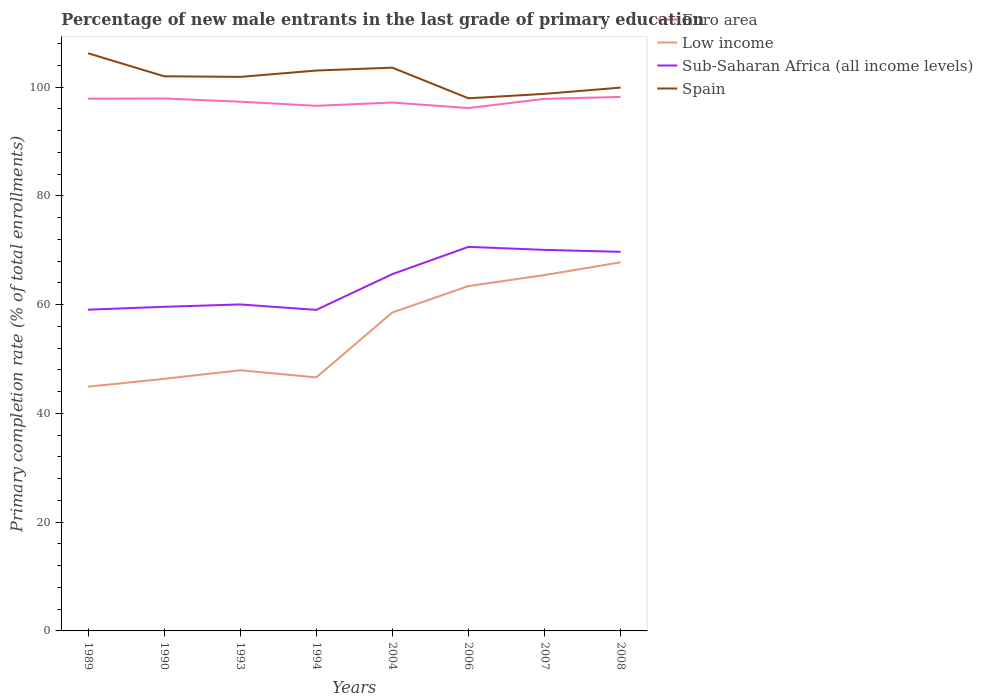How many different coloured lines are there?
Provide a short and direct response. 4. Across all years, what is the maximum percentage of new male entrants in Low income?
Offer a terse response. 44.9. In which year was the percentage of new male entrants in Low income maximum?
Offer a terse response. 1989. What is the total percentage of new male entrants in Low income in the graph?
Make the answer very short. -1.45. What is the difference between the highest and the second highest percentage of new male entrants in Sub-Saharan Africa (all income levels)?
Your response must be concise. 11.58. Is the percentage of new male entrants in Euro area strictly greater than the percentage of new male entrants in Sub-Saharan Africa (all income levels) over the years?
Your answer should be compact. No. How many lines are there?
Keep it short and to the point. 4. What is the difference between two consecutive major ticks on the Y-axis?
Offer a very short reply. 20. Are the values on the major ticks of Y-axis written in scientific E-notation?
Your answer should be compact. No. Where does the legend appear in the graph?
Offer a terse response. Top right. What is the title of the graph?
Keep it short and to the point. Percentage of new male entrants in the last grade of primary education. What is the label or title of the X-axis?
Your answer should be very brief. Years. What is the label or title of the Y-axis?
Give a very brief answer. Primary completion rate (% of total enrollments). What is the Primary completion rate (% of total enrollments) of Euro area in 1989?
Give a very brief answer. 97.86. What is the Primary completion rate (% of total enrollments) in Low income in 1989?
Offer a very short reply. 44.9. What is the Primary completion rate (% of total enrollments) in Sub-Saharan Africa (all income levels) in 1989?
Your answer should be compact. 59.07. What is the Primary completion rate (% of total enrollments) in Spain in 1989?
Provide a succinct answer. 106.22. What is the Primary completion rate (% of total enrollments) of Euro area in 1990?
Your answer should be very brief. 97.9. What is the Primary completion rate (% of total enrollments) of Low income in 1990?
Make the answer very short. 46.35. What is the Primary completion rate (% of total enrollments) of Sub-Saharan Africa (all income levels) in 1990?
Give a very brief answer. 59.6. What is the Primary completion rate (% of total enrollments) of Spain in 1990?
Your answer should be very brief. 101.98. What is the Primary completion rate (% of total enrollments) of Euro area in 1993?
Your answer should be very brief. 97.31. What is the Primary completion rate (% of total enrollments) of Low income in 1993?
Your answer should be very brief. 47.93. What is the Primary completion rate (% of total enrollments) of Sub-Saharan Africa (all income levels) in 1993?
Your answer should be very brief. 60.03. What is the Primary completion rate (% of total enrollments) of Spain in 1993?
Your response must be concise. 101.87. What is the Primary completion rate (% of total enrollments) in Euro area in 1994?
Your response must be concise. 96.55. What is the Primary completion rate (% of total enrollments) of Low income in 1994?
Your answer should be very brief. 46.62. What is the Primary completion rate (% of total enrollments) in Sub-Saharan Africa (all income levels) in 1994?
Offer a terse response. 59.03. What is the Primary completion rate (% of total enrollments) of Spain in 1994?
Offer a very short reply. 103.04. What is the Primary completion rate (% of total enrollments) in Euro area in 2004?
Make the answer very short. 97.16. What is the Primary completion rate (% of total enrollments) in Low income in 2004?
Your answer should be compact. 58.55. What is the Primary completion rate (% of total enrollments) in Sub-Saharan Africa (all income levels) in 2004?
Your response must be concise. 65.61. What is the Primary completion rate (% of total enrollments) of Spain in 2004?
Make the answer very short. 103.57. What is the Primary completion rate (% of total enrollments) of Euro area in 2006?
Your answer should be compact. 96.14. What is the Primary completion rate (% of total enrollments) in Low income in 2006?
Your response must be concise. 63.41. What is the Primary completion rate (% of total enrollments) in Sub-Saharan Africa (all income levels) in 2006?
Give a very brief answer. 70.62. What is the Primary completion rate (% of total enrollments) of Spain in 2006?
Give a very brief answer. 97.93. What is the Primary completion rate (% of total enrollments) of Euro area in 2007?
Your answer should be compact. 97.84. What is the Primary completion rate (% of total enrollments) in Low income in 2007?
Your answer should be compact. 65.43. What is the Primary completion rate (% of total enrollments) in Sub-Saharan Africa (all income levels) in 2007?
Offer a very short reply. 70.06. What is the Primary completion rate (% of total enrollments) of Spain in 2007?
Keep it short and to the point. 98.75. What is the Primary completion rate (% of total enrollments) in Euro area in 2008?
Your answer should be very brief. 98.19. What is the Primary completion rate (% of total enrollments) in Low income in 2008?
Give a very brief answer. 67.78. What is the Primary completion rate (% of total enrollments) in Sub-Saharan Africa (all income levels) in 2008?
Offer a terse response. 69.7. What is the Primary completion rate (% of total enrollments) of Spain in 2008?
Your response must be concise. 99.9. Across all years, what is the maximum Primary completion rate (% of total enrollments) in Euro area?
Make the answer very short. 98.19. Across all years, what is the maximum Primary completion rate (% of total enrollments) in Low income?
Offer a terse response. 67.78. Across all years, what is the maximum Primary completion rate (% of total enrollments) in Sub-Saharan Africa (all income levels)?
Your answer should be very brief. 70.62. Across all years, what is the maximum Primary completion rate (% of total enrollments) in Spain?
Give a very brief answer. 106.22. Across all years, what is the minimum Primary completion rate (% of total enrollments) in Euro area?
Your answer should be compact. 96.14. Across all years, what is the minimum Primary completion rate (% of total enrollments) of Low income?
Your answer should be very brief. 44.9. Across all years, what is the minimum Primary completion rate (% of total enrollments) in Sub-Saharan Africa (all income levels)?
Ensure brevity in your answer.  59.03. Across all years, what is the minimum Primary completion rate (% of total enrollments) in Spain?
Your response must be concise. 97.93. What is the total Primary completion rate (% of total enrollments) in Euro area in the graph?
Offer a terse response. 778.95. What is the total Primary completion rate (% of total enrollments) of Low income in the graph?
Keep it short and to the point. 440.97. What is the total Primary completion rate (% of total enrollments) of Sub-Saharan Africa (all income levels) in the graph?
Give a very brief answer. 513.72. What is the total Primary completion rate (% of total enrollments) in Spain in the graph?
Your answer should be compact. 813.26. What is the difference between the Primary completion rate (% of total enrollments) of Euro area in 1989 and that in 1990?
Your answer should be very brief. -0.04. What is the difference between the Primary completion rate (% of total enrollments) of Low income in 1989 and that in 1990?
Your answer should be very brief. -1.45. What is the difference between the Primary completion rate (% of total enrollments) in Sub-Saharan Africa (all income levels) in 1989 and that in 1990?
Offer a very short reply. -0.53. What is the difference between the Primary completion rate (% of total enrollments) in Spain in 1989 and that in 1990?
Your response must be concise. 4.23. What is the difference between the Primary completion rate (% of total enrollments) in Euro area in 1989 and that in 1993?
Your answer should be compact. 0.55. What is the difference between the Primary completion rate (% of total enrollments) of Low income in 1989 and that in 1993?
Provide a short and direct response. -3.02. What is the difference between the Primary completion rate (% of total enrollments) of Sub-Saharan Africa (all income levels) in 1989 and that in 1993?
Your response must be concise. -0.96. What is the difference between the Primary completion rate (% of total enrollments) of Spain in 1989 and that in 1993?
Make the answer very short. 4.35. What is the difference between the Primary completion rate (% of total enrollments) of Euro area in 1989 and that in 1994?
Ensure brevity in your answer.  1.31. What is the difference between the Primary completion rate (% of total enrollments) of Low income in 1989 and that in 1994?
Ensure brevity in your answer.  -1.72. What is the difference between the Primary completion rate (% of total enrollments) in Sub-Saharan Africa (all income levels) in 1989 and that in 1994?
Offer a very short reply. 0.03. What is the difference between the Primary completion rate (% of total enrollments) of Spain in 1989 and that in 1994?
Give a very brief answer. 3.18. What is the difference between the Primary completion rate (% of total enrollments) of Euro area in 1989 and that in 2004?
Ensure brevity in your answer.  0.7. What is the difference between the Primary completion rate (% of total enrollments) of Low income in 1989 and that in 2004?
Your answer should be compact. -13.65. What is the difference between the Primary completion rate (% of total enrollments) of Sub-Saharan Africa (all income levels) in 1989 and that in 2004?
Your answer should be compact. -6.54. What is the difference between the Primary completion rate (% of total enrollments) in Spain in 1989 and that in 2004?
Make the answer very short. 2.65. What is the difference between the Primary completion rate (% of total enrollments) of Euro area in 1989 and that in 2006?
Make the answer very short. 1.73. What is the difference between the Primary completion rate (% of total enrollments) in Low income in 1989 and that in 2006?
Make the answer very short. -18.51. What is the difference between the Primary completion rate (% of total enrollments) of Sub-Saharan Africa (all income levels) in 1989 and that in 2006?
Provide a short and direct response. -11.55. What is the difference between the Primary completion rate (% of total enrollments) of Spain in 1989 and that in 2006?
Keep it short and to the point. 8.28. What is the difference between the Primary completion rate (% of total enrollments) in Euro area in 1989 and that in 2007?
Your answer should be very brief. 0.03. What is the difference between the Primary completion rate (% of total enrollments) in Low income in 1989 and that in 2007?
Your answer should be very brief. -20.53. What is the difference between the Primary completion rate (% of total enrollments) in Sub-Saharan Africa (all income levels) in 1989 and that in 2007?
Offer a terse response. -11. What is the difference between the Primary completion rate (% of total enrollments) in Spain in 1989 and that in 2007?
Your answer should be compact. 7.47. What is the difference between the Primary completion rate (% of total enrollments) in Euro area in 1989 and that in 2008?
Ensure brevity in your answer.  -0.32. What is the difference between the Primary completion rate (% of total enrollments) in Low income in 1989 and that in 2008?
Offer a terse response. -22.88. What is the difference between the Primary completion rate (% of total enrollments) of Sub-Saharan Africa (all income levels) in 1989 and that in 2008?
Your answer should be very brief. -10.64. What is the difference between the Primary completion rate (% of total enrollments) in Spain in 1989 and that in 2008?
Your answer should be very brief. 6.32. What is the difference between the Primary completion rate (% of total enrollments) in Euro area in 1990 and that in 1993?
Provide a succinct answer. 0.59. What is the difference between the Primary completion rate (% of total enrollments) in Low income in 1990 and that in 1993?
Give a very brief answer. -1.57. What is the difference between the Primary completion rate (% of total enrollments) of Sub-Saharan Africa (all income levels) in 1990 and that in 1993?
Provide a short and direct response. -0.43. What is the difference between the Primary completion rate (% of total enrollments) in Spain in 1990 and that in 1993?
Offer a very short reply. 0.11. What is the difference between the Primary completion rate (% of total enrollments) of Euro area in 1990 and that in 1994?
Your response must be concise. 1.35. What is the difference between the Primary completion rate (% of total enrollments) in Low income in 1990 and that in 1994?
Offer a very short reply. -0.27. What is the difference between the Primary completion rate (% of total enrollments) in Sub-Saharan Africa (all income levels) in 1990 and that in 1994?
Provide a succinct answer. 0.56. What is the difference between the Primary completion rate (% of total enrollments) of Spain in 1990 and that in 1994?
Provide a short and direct response. -1.05. What is the difference between the Primary completion rate (% of total enrollments) of Euro area in 1990 and that in 2004?
Ensure brevity in your answer.  0.74. What is the difference between the Primary completion rate (% of total enrollments) in Low income in 1990 and that in 2004?
Keep it short and to the point. -12.2. What is the difference between the Primary completion rate (% of total enrollments) of Sub-Saharan Africa (all income levels) in 1990 and that in 2004?
Keep it short and to the point. -6.01. What is the difference between the Primary completion rate (% of total enrollments) in Spain in 1990 and that in 2004?
Keep it short and to the point. -1.58. What is the difference between the Primary completion rate (% of total enrollments) of Euro area in 1990 and that in 2006?
Provide a short and direct response. 1.77. What is the difference between the Primary completion rate (% of total enrollments) in Low income in 1990 and that in 2006?
Make the answer very short. -17.06. What is the difference between the Primary completion rate (% of total enrollments) of Sub-Saharan Africa (all income levels) in 1990 and that in 2006?
Make the answer very short. -11.02. What is the difference between the Primary completion rate (% of total enrollments) of Spain in 1990 and that in 2006?
Offer a terse response. 4.05. What is the difference between the Primary completion rate (% of total enrollments) of Euro area in 1990 and that in 2007?
Offer a terse response. 0.06. What is the difference between the Primary completion rate (% of total enrollments) of Low income in 1990 and that in 2007?
Your answer should be very brief. -19.08. What is the difference between the Primary completion rate (% of total enrollments) in Sub-Saharan Africa (all income levels) in 1990 and that in 2007?
Provide a succinct answer. -10.47. What is the difference between the Primary completion rate (% of total enrollments) of Spain in 1990 and that in 2007?
Offer a very short reply. 3.23. What is the difference between the Primary completion rate (% of total enrollments) of Euro area in 1990 and that in 2008?
Your response must be concise. -0.29. What is the difference between the Primary completion rate (% of total enrollments) of Low income in 1990 and that in 2008?
Offer a terse response. -21.43. What is the difference between the Primary completion rate (% of total enrollments) of Sub-Saharan Africa (all income levels) in 1990 and that in 2008?
Provide a succinct answer. -10.11. What is the difference between the Primary completion rate (% of total enrollments) of Spain in 1990 and that in 2008?
Your answer should be very brief. 2.09. What is the difference between the Primary completion rate (% of total enrollments) of Euro area in 1993 and that in 1994?
Your answer should be very brief. 0.76. What is the difference between the Primary completion rate (% of total enrollments) of Low income in 1993 and that in 1994?
Make the answer very short. 1.31. What is the difference between the Primary completion rate (% of total enrollments) in Sub-Saharan Africa (all income levels) in 1993 and that in 1994?
Give a very brief answer. 1. What is the difference between the Primary completion rate (% of total enrollments) in Spain in 1993 and that in 1994?
Offer a terse response. -1.17. What is the difference between the Primary completion rate (% of total enrollments) of Euro area in 1993 and that in 2004?
Keep it short and to the point. 0.15. What is the difference between the Primary completion rate (% of total enrollments) of Low income in 1993 and that in 2004?
Your response must be concise. -10.63. What is the difference between the Primary completion rate (% of total enrollments) in Sub-Saharan Africa (all income levels) in 1993 and that in 2004?
Offer a terse response. -5.58. What is the difference between the Primary completion rate (% of total enrollments) in Spain in 1993 and that in 2004?
Your response must be concise. -1.7. What is the difference between the Primary completion rate (% of total enrollments) in Euro area in 1993 and that in 2006?
Your answer should be compact. 1.17. What is the difference between the Primary completion rate (% of total enrollments) in Low income in 1993 and that in 2006?
Your answer should be very brief. -15.49. What is the difference between the Primary completion rate (% of total enrollments) of Sub-Saharan Africa (all income levels) in 1993 and that in 2006?
Keep it short and to the point. -10.59. What is the difference between the Primary completion rate (% of total enrollments) of Spain in 1993 and that in 2006?
Your answer should be compact. 3.94. What is the difference between the Primary completion rate (% of total enrollments) of Euro area in 1993 and that in 2007?
Your answer should be very brief. -0.53. What is the difference between the Primary completion rate (% of total enrollments) in Low income in 1993 and that in 2007?
Offer a terse response. -17.5. What is the difference between the Primary completion rate (% of total enrollments) in Sub-Saharan Africa (all income levels) in 1993 and that in 2007?
Provide a succinct answer. -10.03. What is the difference between the Primary completion rate (% of total enrollments) in Spain in 1993 and that in 2007?
Your answer should be very brief. 3.12. What is the difference between the Primary completion rate (% of total enrollments) in Euro area in 1993 and that in 2008?
Provide a short and direct response. -0.88. What is the difference between the Primary completion rate (% of total enrollments) in Low income in 1993 and that in 2008?
Give a very brief answer. -19.85. What is the difference between the Primary completion rate (% of total enrollments) of Sub-Saharan Africa (all income levels) in 1993 and that in 2008?
Ensure brevity in your answer.  -9.67. What is the difference between the Primary completion rate (% of total enrollments) of Spain in 1993 and that in 2008?
Offer a very short reply. 1.97. What is the difference between the Primary completion rate (% of total enrollments) of Euro area in 1994 and that in 2004?
Offer a very short reply. -0.61. What is the difference between the Primary completion rate (% of total enrollments) in Low income in 1994 and that in 2004?
Offer a very short reply. -11.93. What is the difference between the Primary completion rate (% of total enrollments) of Sub-Saharan Africa (all income levels) in 1994 and that in 2004?
Keep it short and to the point. -6.57. What is the difference between the Primary completion rate (% of total enrollments) of Spain in 1994 and that in 2004?
Offer a terse response. -0.53. What is the difference between the Primary completion rate (% of total enrollments) of Euro area in 1994 and that in 2006?
Offer a very short reply. 0.41. What is the difference between the Primary completion rate (% of total enrollments) of Low income in 1994 and that in 2006?
Your response must be concise. -16.79. What is the difference between the Primary completion rate (% of total enrollments) in Sub-Saharan Africa (all income levels) in 1994 and that in 2006?
Your answer should be compact. -11.58. What is the difference between the Primary completion rate (% of total enrollments) in Spain in 1994 and that in 2006?
Ensure brevity in your answer.  5.1. What is the difference between the Primary completion rate (% of total enrollments) in Euro area in 1994 and that in 2007?
Make the answer very short. -1.29. What is the difference between the Primary completion rate (% of total enrollments) of Low income in 1994 and that in 2007?
Provide a succinct answer. -18.81. What is the difference between the Primary completion rate (% of total enrollments) in Sub-Saharan Africa (all income levels) in 1994 and that in 2007?
Give a very brief answer. -11.03. What is the difference between the Primary completion rate (% of total enrollments) of Spain in 1994 and that in 2007?
Your response must be concise. 4.29. What is the difference between the Primary completion rate (% of total enrollments) in Euro area in 1994 and that in 2008?
Provide a succinct answer. -1.64. What is the difference between the Primary completion rate (% of total enrollments) in Low income in 1994 and that in 2008?
Make the answer very short. -21.16. What is the difference between the Primary completion rate (% of total enrollments) of Sub-Saharan Africa (all income levels) in 1994 and that in 2008?
Make the answer very short. -10.67. What is the difference between the Primary completion rate (% of total enrollments) of Spain in 1994 and that in 2008?
Offer a very short reply. 3.14. What is the difference between the Primary completion rate (% of total enrollments) of Euro area in 2004 and that in 2006?
Your response must be concise. 1.02. What is the difference between the Primary completion rate (% of total enrollments) of Low income in 2004 and that in 2006?
Provide a short and direct response. -4.86. What is the difference between the Primary completion rate (% of total enrollments) in Sub-Saharan Africa (all income levels) in 2004 and that in 2006?
Your answer should be compact. -5.01. What is the difference between the Primary completion rate (% of total enrollments) of Spain in 2004 and that in 2006?
Make the answer very short. 5.63. What is the difference between the Primary completion rate (% of total enrollments) in Euro area in 2004 and that in 2007?
Offer a terse response. -0.68. What is the difference between the Primary completion rate (% of total enrollments) in Low income in 2004 and that in 2007?
Your answer should be very brief. -6.88. What is the difference between the Primary completion rate (% of total enrollments) of Sub-Saharan Africa (all income levels) in 2004 and that in 2007?
Provide a succinct answer. -4.46. What is the difference between the Primary completion rate (% of total enrollments) of Spain in 2004 and that in 2007?
Provide a short and direct response. 4.82. What is the difference between the Primary completion rate (% of total enrollments) in Euro area in 2004 and that in 2008?
Offer a terse response. -1.03. What is the difference between the Primary completion rate (% of total enrollments) in Low income in 2004 and that in 2008?
Offer a very short reply. -9.23. What is the difference between the Primary completion rate (% of total enrollments) in Sub-Saharan Africa (all income levels) in 2004 and that in 2008?
Provide a succinct answer. -4.1. What is the difference between the Primary completion rate (% of total enrollments) in Spain in 2004 and that in 2008?
Ensure brevity in your answer.  3.67. What is the difference between the Primary completion rate (% of total enrollments) of Euro area in 2006 and that in 2007?
Offer a very short reply. -1.7. What is the difference between the Primary completion rate (% of total enrollments) in Low income in 2006 and that in 2007?
Ensure brevity in your answer.  -2.02. What is the difference between the Primary completion rate (% of total enrollments) of Sub-Saharan Africa (all income levels) in 2006 and that in 2007?
Ensure brevity in your answer.  0.55. What is the difference between the Primary completion rate (% of total enrollments) of Spain in 2006 and that in 2007?
Offer a very short reply. -0.82. What is the difference between the Primary completion rate (% of total enrollments) of Euro area in 2006 and that in 2008?
Make the answer very short. -2.05. What is the difference between the Primary completion rate (% of total enrollments) of Low income in 2006 and that in 2008?
Provide a short and direct response. -4.37. What is the difference between the Primary completion rate (% of total enrollments) of Sub-Saharan Africa (all income levels) in 2006 and that in 2008?
Make the answer very short. 0.91. What is the difference between the Primary completion rate (% of total enrollments) of Spain in 2006 and that in 2008?
Your answer should be very brief. -1.97. What is the difference between the Primary completion rate (% of total enrollments) in Euro area in 2007 and that in 2008?
Provide a short and direct response. -0.35. What is the difference between the Primary completion rate (% of total enrollments) in Low income in 2007 and that in 2008?
Provide a short and direct response. -2.35. What is the difference between the Primary completion rate (% of total enrollments) of Sub-Saharan Africa (all income levels) in 2007 and that in 2008?
Make the answer very short. 0.36. What is the difference between the Primary completion rate (% of total enrollments) of Spain in 2007 and that in 2008?
Your response must be concise. -1.15. What is the difference between the Primary completion rate (% of total enrollments) of Euro area in 1989 and the Primary completion rate (% of total enrollments) of Low income in 1990?
Offer a terse response. 51.51. What is the difference between the Primary completion rate (% of total enrollments) of Euro area in 1989 and the Primary completion rate (% of total enrollments) of Sub-Saharan Africa (all income levels) in 1990?
Your response must be concise. 38.27. What is the difference between the Primary completion rate (% of total enrollments) of Euro area in 1989 and the Primary completion rate (% of total enrollments) of Spain in 1990?
Offer a very short reply. -4.12. What is the difference between the Primary completion rate (% of total enrollments) of Low income in 1989 and the Primary completion rate (% of total enrollments) of Sub-Saharan Africa (all income levels) in 1990?
Give a very brief answer. -14.69. What is the difference between the Primary completion rate (% of total enrollments) in Low income in 1989 and the Primary completion rate (% of total enrollments) in Spain in 1990?
Offer a terse response. -57.08. What is the difference between the Primary completion rate (% of total enrollments) of Sub-Saharan Africa (all income levels) in 1989 and the Primary completion rate (% of total enrollments) of Spain in 1990?
Keep it short and to the point. -42.92. What is the difference between the Primary completion rate (% of total enrollments) of Euro area in 1989 and the Primary completion rate (% of total enrollments) of Low income in 1993?
Provide a succinct answer. 49.94. What is the difference between the Primary completion rate (% of total enrollments) of Euro area in 1989 and the Primary completion rate (% of total enrollments) of Sub-Saharan Africa (all income levels) in 1993?
Offer a terse response. 37.83. What is the difference between the Primary completion rate (% of total enrollments) of Euro area in 1989 and the Primary completion rate (% of total enrollments) of Spain in 1993?
Your answer should be very brief. -4.01. What is the difference between the Primary completion rate (% of total enrollments) of Low income in 1989 and the Primary completion rate (% of total enrollments) of Sub-Saharan Africa (all income levels) in 1993?
Keep it short and to the point. -15.13. What is the difference between the Primary completion rate (% of total enrollments) of Low income in 1989 and the Primary completion rate (% of total enrollments) of Spain in 1993?
Give a very brief answer. -56.97. What is the difference between the Primary completion rate (% of total enrollments) in Sub-Saharan Africa (all income levels) in 1989 and the Primary completion rate (% of total enrollments) in Spain in 1993?
Provide a succinct answer. -42.8. What is the difference between the Primary completion rate (% of total enrollments) in Euro area in 1989 and the Primary completion rate (% of total enrollments) in Low income in 1994?
Make the answer very short. 51.24. What is the difference between the Primary completion rate (% of total enrollments) of Euro area in 1989 and the Primary completion rate (% of total enrollments) of Sub-Saharan Africa (all income levels) in 1994?
Provide a short and direct response. 38.83. What is the difference between the Primary completion rate (% of total enrollments) of Euro area in 1989 and the Primary completion rate (% of total enrollments) of Spain in 1994?
Ensure brevity in your answer.  -5.17. What is the difference between the Primary completion rate (% of total enrollments) of Low income in 1989 and the Primary completion rate (% of total enrollments) of Sub-Saharan Africa (all income levels) in 1994?
Give a very brief answer. -14.13. What is the difference between the Primary completion rate (% of total enrollments) of Low income in 1989 and the Primary completion rate (% of total enrollments) of Spain in 1994?
Your answer should be compact. -58.13. What is the difference between the Primary completion rate (% of total enrollments) of Sub-Saharan Africa (all income levels) in 1989 and the Primary completion rate (% of total enrollments) of Spain in 1994?
Give a very brief answer. -43.97. What is the difference between the Primary completion rate (% of total enrollments) in Euro area in 1989 and the Primary completion rate (% of total enrollments) in Low income in 2004?
Provide a short and direct response. 39.31. What is the difference between the Primary completion rate (% of total enrollments) in Euro area in 1989 and the Primary completion rate (% of total enrollments) in Sub-Saharan Africa (all income levels) in 2004?
Provide a succinct answer. 32.26. What is the difference between the Primary completion rate (% of total enrollments) of Euro area in 1989 and the Primary completion rate (% of total enrollments) of Spain in 2004?
Your answer should be compact. -5.7. What is the difference between the Primary completion rate (% of total enrollments) of Low income in 1989 and the Primary completion rate (% of total enrollments) of Sub-Saharan Africa (all income levels) in 2004?
Offer a terse response. -20.7. What is the difference between the Primary completion rate (% of total enrollments) in Low income in 1989 and the Primary completion rate (% of total enrollments) in Spain in 2004?
Your response must be concise. -58.66. What is the difference between the Primary completion rate (% of total enrollments) in Sub-Saharan Africa (all income levels) in 1989 and the Primary completion rate (% of total enrollments) in Spain in 2004?
Your response must be concise. -44.5. What is the difference between the Primary completion rate (% of total enrollments) of Euro area in 1989 and the Primary completion rate (% of total enrollments) of Low income in 2006?
Your answer should be very brief. 34.45. What is the difference between the Primary completion rate (% of total enrollments) in Euro area in 1989 and the Primary completion rate (% of total enrollments) in Sub-Saharan Africa (all income levels) in 2006?
Your answer should be compact. 27.25. What is the difference between the Primary completion rate (% of total enrollments) of Euro area in 1989 and the Primary completion rate (% of total enrollments) of Spain in 2006?
Provide a short and direct response. -0.07. What is the difference between the Primary completion rate (% of total enrollments) of Low income in 1989 and the Primary completion rate (% of total enrollments) of Sub-Saharan Africa (all income levels) in 2006?
Your answer should be compact. -25.71. What is the difference between the Primary completion rate (% of total enrollments) in Low income in 1989 and the Primary completion rate (% of total enrollments) in Spain in 2006?
Your answer should be compact. -53.03. What is the difference between the Primary completion rate (% of total enrollments) of Sub-Saharan Africa (all income levels) in 1989 and the Primary completion rate (% of total enrollments) of Spain in 2006?
Offer a very short reply. -38.87. What is the difference between the Primary completion rate (% of total enrollments) of Euro area in 1989 and the Primary completion rate (% of total enrollments) of Low income in 2007?
Give a very brief answer. 32.43. What is the difference between the Primary completion rate (% of total enrollments) of Euro area in 1989 and the Primary completion rate (% of total enrollments) of Sub-Saharan Africa (all income levels) in 2007?
Make the answer very short. 27.8. What is the difference between the Primary completion rate (% of total enrollments) in Euro area in 1989 and the Primary completion rate (% of total enrollments) in Spain in 2007?
Offer a terse response. -0.89. What is the difference between the Primary completion rate (% of total enrollments) in Low income in 1989 and the Primary completion rate (% of total enrollments) in Sub-Saharan Africa (all income levels) in 2007?
Keep it short and to the point. -25.16. What is the difference between the Primary completion rate (% of total enrollments) in Low income in 1989 and the Primary completion rate (% of total enrollments) in Spain in 2007?
Your answer should be compact. -53.85. What is the difference between the Primary completion rate (% of total enrollments) in Sub-Saharan Africa (all income levels) in 1989 and the Primary completion rate (% of total enrollments) in Spain in 2007?
Make the answer very short. -39.68. What is the difference between the Primary completion rate (% of total enrollments) of Euro area in 1989 and the Primary completion rate (% of total enrollments) of Low income in 2008?
Your answer should be very brief. 30.08. What is the difference between the Primary completion rate (% of total enrollments) in Euro area in 1989 and the Primary completion rate (% of total enrollments) in Sub-Saharan Africa (all income levels) in 2008?
Offer a very short reply. 28.16. What is the difference between the Primary completion rate (% of total enrollments) of Euro area in 1989 and the Primary completion rate (% of total enrollments) of Spain in 2008?
Keep it short and to the point. -2.04. What is the difference between the Primary completion rate (% of total enrollments) of Low income in 1989 and the Primary completion rate (% of total enrollments) of Sub-Saharan Africa (all income levels) in 2008?
Your answer should be very brief. -24.8. What is the difference between the Primary completion rate (% of total enrollments) in Low income in 1989 and the Primary completion rate (% of total enrollments) in Spain in 2008?
Your response must be concise. -55. What is the difference between the Primary completion rate (% of total enrollments) in Sub-Saharan Africa (all income levels) in 1989 and the Primary completion rate (% of total enrollments) in Spain in 2008?
Your answer should be compact. -40.83. What is the difference between the Primary completion rate (% of total enrollments) of Euro area in 1990 and the Primary completion rate (% of total enrollments) of Low income in 1993?
Your response must be concise. 49.98. What is the difference between the Primary completion rate (% of total enrollments) in Euro area in 1990 and the Primary completion rate (% of total enrollments) in Sub-Saharan Africa (all income levels) in 1993?
Ensure brevity in your answer.  37.87. What is the difference between the Primary completion rate (% of total enrollments) in Euro area in 1990 and the Primary completion rate (% of total enrollments) in Spain in 1993?
Your response must be concise. -3.97. What is the difference between the Primary completion rate (% of total enrollments) of Low income in 1990 and the Primary completion rate (% of total enrollments) of Sub-Saharan Africa (all income levels) in 1993?
Your answer should be very brief. -13.68. What is the difference between the Primary completion rate (% of total enrollments) in Low income in 1990 and the Primary completion rate (% of total enrollments) in Spain in 1993?
Make the answer very short. -55.52. What is the difference between the Primary completion rate (% of total enrollments) of Sub-Saharan Africa (all income levels) in 1990 and the Primary completion rate (% of total enrollments) of Spain in 1993?
Keep it short and to the point. -42.27. What is the difference between the Primary completion rate (% of total enrollments) in Euro area in 1990 and the Primary completion rate (% of total enrollments) in Low income in 1994?
Keep it short and to the point. 51.28. What is the difference between the Primary completion rate (% of total enrollments) of Euro area in 1990 and the Primary completion rate (% of total enrollments) of Sub-Saharan Africa (all income levels) in 1994?
Ensure brevity in your answer.  38.87. What is the difference between the Primary completion rate (% of total enrollments) in Euro area in 1990 and the Primary completion rate (% of total enrollments) in Spain in 1994?
Your answer should be very brief. -5.13. What is the difference between the Primary completion rate (% of total enrollments) of Low income in 1990 and the Primary completion rate (% of total enrollments) of Sub-Saharan Africa (all income levels) in 1994?
Provide a short and direct response. -12.68. What is the difference between the Primary completion rate (% of total enrollments) in Low income in 1990 and the Primary completion rate (% of total enrollments) in Spain in 1994?
Ensure brevity in your answer.  -56.68. What is the difference between the Primary completion rate (% of total enrollments) in Sub-Saharan Africa (all income levels) in 1990 and the Primary completion rate (% of total enrollments) in Spain in 1994?
Offer a very short reply. -43.44. What is the difference between the Primary completion rate (% of total enrollments) in Euro area in 1990 and the Primary completion rate (% of total enrollments) in Low income in 2004?
Offer a terse response. 39.35. What is the difference between the Primary completion rate (% of total enrollments) of Euro area in 1990 and the Primary completion rate (% of total enrollments) of Sub-Saharan Africa (all income levels) in 2004?
Your answer should be compact. 32.3. What is the difference between the Primary completion rate (% of total enrollments) in Euro area in 1990 and the Primary completion rate (% of total enrollments) in Spain in 2004?
Provide a succinct answer. -5.67. What is the difference between the Primary completion rate (% of total enrollments) of Low income in 1990 and the Primary completion rate (% of total enrollments) of Sub-Saharan Africa (all income levels) in 2004?
Your answer should be compact. -19.25. What is the difference between the Primary completion rate (% of total enrollments) of Low income in 1990 and the Primary completion rate (% of total enrollments) of Spain in 2004?
Your answer should be compact. -57.22. What is the difference between the Primary completion rate (% of total enrollments) of Sub-Saharan Africa (all income levels) in 1990 and the Primary completion rate (% of total enrollments) of Spain in 2004?
Your response must be concise. -43.97. What is the difference between the Primary completion rate (% of total enrollments) of Euro area in 1990 and the Primary completion rate (% of total enrollments) of Low income in 2006?
Provide a short and direct response. 34.49. What is the difference between the Primary completion rate (% of total enrollments) in Euro area in 1990 and the Primary completion rate (% of total enrollments) in Sub-Saharan Africa (all income levels) in 2006?
Ensure brevity in your answer.  27.28. What is the difference between the Primary completion rate (% of total enrollments) of Euro area in 1990 and the Primary completion rate (% of total enrollments) of Spain in 2006?
Keep it short and to the point. -0.03. What is the difference between the Primary completion rate (% of total enrollments) of Low income in 1990 and the Primary completion rate (% of total enrollments) of Sub-Saharan Africa (all income levels) in 2006?
Keep it short and to the point. -24.26. What is the difference between the Primary completion rate (% of total enrollments) of Low income in 1990 and the Primary completion rate (% of total enrollments) of Spain in 2006?
Give a very brief answer. -51.58. What is the difference between the Primary completion rate (% of total enrollments) in Sub-Saharan Africa (all income levels) in 1990 and the Primary completion rate (% of total enrollments) in Spain in 2006?
Make the answer very short. -38.34. What is the difference between the Primary completion rate (% of total enrollments) of Euro area in 1990 and the Primary completion rate (% of total enrollments) of Low income in 2007?
Your response must be concise. 32.47. What is the difference between the Primary completion rate (% of total enrollments) in Euro area in 1990 and the Primary completion rate (% of total enrollments) in Sub-Saharan Africa (all income levels) in 2007?
Ensure brevity in your answer.  27.84. What is the difference between the Primary completion rate (% of total enrollments) in Euro area in 1990 and the Primary completion rate (% of total enrollments) in Spain in 2007?
Give a very brief answer. -0.85. What is the difference between the Primary completion rate (% of total enrollments) in Low income in 1990 and the Primary completion rate (% of total enrollments) in Sub-Saharan Africa (all income levels) in 2007?
Keep it short and to the point. -23.71. What is the difference between the Primary completion rate (% of total enrollments) of Low income in 1990 and the Primary completion rate (% of total enrollments) of Spain in 2007?
Provide a short and direct response. -52.4. What is the difference between the Primary completion rate (% of total enrollments) in Sub-Saharan Africa (all income levels) in 1990 and the Primary completion rate (% of total enrollments) in Spain in 2007?
Offer a terse response. -39.15. What is the difference between the Primary completion rate (% of total enrollments) in Euro area in 1990 and the Primary completion rate (% of total enrollments) in Low income in 2008?
Keep it short and to the point. 30.12. What is the difference between the Primary completion rate (% of total enrollments) in Euro area in 1990 and the Primary completion rate (% of total enrollments) in Sub-Saharan Africa (all income levels) in 2008?
Provide a short and direct response. 28.2. What is the difference between the Primary completion rate (% of total enrollments) in Euro area in 1990 and the Primary completion rate (% of total enrollments) in Spain in 2008?
Your answer should be very brief. -2. What is the difference between the Primary completion rate (% of total enrollments) of Low income in 1990 and the Primary completion rate (% of total enrollments) of Sub-Saharan Africa (all income levels) in 2008?
Make the answer very short. -23.35. What is the difference between the Primary completion rate (% of total enrollments) in Low income in 1990 and the Primary completion rate (% of total enrollments) in Spain in 2008?
Offer a terse response. -53.55. What is the difference between the Primary completion rate (% of total enrollments) of Sub-Saharan Africa (all income levels) in 1990 and the Primary completion rate (% of total enrollments) of Spain in 2008?
Give a very brief answer. -40.3. What is the difference between the Primary completion rate (% of total enrollments) of Euro area in 1993 and the Primary completion rate (% of total enrollments) of Low income in 1994?
Your answer should be compact. 50.69. What is the difference between the Primary completion rate (% of total enrollments) in Euro area in 1993 and the Primary completion rate (% of total enrollments) in Sub-Saharan Africa (all income levels) in 1994?
Give a very brief answer. 38.28. What is the difference between the Primary completion rate (% of total enrollments) in Euro area in 1993 and the Primary completion rate (% of total enrollments) in Spain in 1994?
Provide a succinct answer. -5.73. What is the difference between the Primary completion rate (% of total enrollments) of Low income in 1993 and the Primary completion rate (% of total enrollments) of Sub-Saharan Africa (all income levels) in 1994?
Give a very brief answer. -11.11. What is the difference between the Primary completion rate (% of total enrollments) of Low income in 1993 and the Primary completion rate (% of total enrollments) of Spain in 1994?
Provide a short and direct response. -55.11. What is the difference between the Primary completion rate (% of total enrollments) in Sub-Saharan Africa (all income levels) in 1993 and the Primary completion rate (% of total enrollments) in Spain in 1994?
Make the answer very short. -43.01. What is the difference between the Primary completion rate (% of total enrollments) of Euro area in 1993 and the Primary completion rate (% of total enrollments) of Low income in 2004?
Provide a short and direct response. 38.76. What is the difference between the Primary completion rate (% of total enrollments) of Euro area in 1993 and the Primary completion rate (% of total enrollments) of Sub-Saharan Africa (all income levels) in 2004?
Your response must be concise. 31.7. What is the difference between the Primary completion rate (% of total enrollments) of Euro area in 1993 and the Primary completion rate (% of total enrollments) of Spain in 2004?
Give a very brief answer. -6.26. What is the difference between the Primary completion rate (% of total enrollments) in Low income in 1993 and the Primary completion rate (% of total enrollments) in Sub-Saharan Africa (all income levels) in 2004?
Give a very brief answer. -17.68. What is the difference between the Primary completion rate (% of total enrollments) of Low income in 1993 and the Primary completion rate (% of total enrollments) of Spain in 2004?
Your response must be concise. -55.64. What is the difference between the Primary completion rate (% of total enrollments) in Sub-Saharan Africa (all income levels) in 1993 and the Primary completion rate (% of total enrollments) in Spain in 2004?
Make the answer very short. -43.54. What is the difference between the Primary completion rate (% of total enrollments) in Euro area in 1993 and the Primary completion rate (% of total enrollments) in Low income in 2006?
Your response must be concise. 33.9. What is the difference between the Primary completion rate (% of total enrollments) in Euro area in 1993 and the Primary completion rate (% of total enrollments) in Sub-Saharan Africa (all income levels) in 2006?
Give a very brief answer. 26.69. What is the difference between the Primary completion rate (% of total enrollments) of Euro area in 1993 and the Primary completion rate (% of total enrollments) of Spain in 2006?
Your answer should be compact. -0.62. What is the difference between the Primary completion rate (% of total enrollments) in Low income in 1993 and the Primary completion rate (% of total enrollments) in Sub-Saharan Africa (all income levels) in 2006?
Offer a terse response. -22.69. What is the difference between the Primary completion rate (% of total enrollments) in Low income in 1993 and the Primary completion rate (% of total enrollments) in Spain in 2006?
Your answer should be very brief. -50.01. What is the difference between the Primary completion rate (% of total enrollments) of Sub-Saharan Africa (all income levels) in 1993 and the Primary completion rate (% of total enrollments) of Spain in 2006?
Your answer should be compact. -37.9. What is the difference between the Primary completion rate (% of total enrollments) of Euro area in 1993 and the Primary completion rate (% of total enrollments) of Low income in 2007?
Give a very brief answer. 31.88. What is the difference between the Primary completion rate (% of total enrollments) of Euro area in 1993 and the Primary completion rate (% of total enrollments) of Sub-Saharan Africa (all income levels) in 2007?
Your answer should be compact. 27.25. What is the difference between the Primary completion rate (% of total enrollments) of Euro area in 1993 and the Primary completion rate (% of total enrollments) of Spain in 2007?
Your answer should be compact. -1.44. What is the difference between the Primary completion rate (% of total enrollments) of Low income in 1993 and the Primary completion rate (% of total enrollments) of Sub-Saharan Africa (all income levels) in 2007?
Keep it short and to the point. -22.14. What is the difference between the Primary completion rate (% of total enrollments) of Low income in 1993 and the Primary completion rate (% of total enrollments) of Spain in 2007?
Make the answer very short. -50.83. What is the difference between the Primary completion rate (% of total enrollments) in Sub-Saharan Africa (all income levels) in 1993 and the Primary completion rate (% of total enrollments) in Spain in 2007?
Keep it short and to the point. -38.72. What is the difference between the Primary completion rate (% of total enrollments) of Euro area in 1993 and the Primary completion rate (% of total enrollments) of Low income in 2008?
Provide a short and direct response. 29.53. What is the difference between the Primary completion rate (% of total enrollments) of Euro area in 1993 and the Primary completion rate (% of total enrollments) of Sub-Saharan Africa (all income levels) in 2008?
Provide a short and direct response. 27.61. What is the difference between the Primary completion rate (% of total enrollments) of Euro area in 1993 and the Primary completion rate (% of total enrollments) of Spain in 2008?
Ensure brevity in your answer.  -2.59. What is the difference between the Primary completion rate (% of total enrollments) in Low income in 1993 and the Primary completion rate (% of total enrollments) in Sub-Saharan Africa (all income levels) in 2008?
Offer a very short reply. -21.78. What is the difference between the Primary completion rate (% of total enrollments) in Low income in 1993 and the Primary completion rate (% of total enrollments) in Spain in 2008?
Offer a very short reply. -51.97. What is the difference between the Primary completion rate (% of total enrollments) in Sub-Saharan Africa (all income levels) in 1993 and the Primary completion rate (% of total enrollments) in Spain in 2008?
Give a very brief answer. -39.87. What is the difference between the Primary completion rate (% of total enrollments) of Euro area in 1994 and the Primary completion rate (% of total enrollments) of Low income in 2004?
Your response must be concise. 38. What is the difference between the Primary completion rate (% of total enrollments) of Euro area in 1994 and the Primary completion rate (% of total enrollments) of Sub-Saharan Africa (all income levels) in 2004?
Your response must be concise. 30.94. What is the difference between the Primary completion rate (% of total enrollments) of Euro area in 1994 and the Primary completion rate (% of total enrollments) of Spain in 2004?
Give a very brief answer. -7.02. What is the difference between the Primary completion rate (% of total enrollments) in Low income in 1994 and the Primary completion rate (% of total enrollments) in Sub-Saharan Africa (all income levels) in 2004?
Make the answer very short. -18.99. What is the difference between the Primary completion rate (% of total enrollments) of Low income in 1994 and the Primary completion rate (% of total enrollments) of Spain in 2004?
Give a very brief answer. -56.95. What is the difference between the Primary completion rate (% of total enrollments) in Sub-Saharan Africa (all income levels) in 1994 and the Primary completion rate (% of total enrollments) in Spain in 2004?
Keep it short and to the point. -44.53. What is the difference between the Primary completion rate (% of total enrollments) in Euro area in 1994 and the Primary completion rate (% of total enrollments) in Low income in 2006?
Give a very brief answer. 33.14. What is the difference between the Primary completion rate (% of total enrollments) in Euro area in 1994 and the Primary completion rate (% of total enrollments) in Sub-Saharan Africa (all income levels) in 2006?
Give a very brief answer. 25.93. What is the difference between the Primary completion rate (% of total enrollments) of Euro area in 1994 and the Primary completion rate (% of total enrollments) of Spain in 2006?
Provide a succinct answer. -1.39. What is the difference between the Primary completion rate (% of total enrollments) in Low income in 1994 and the Primary completion rate (% of total enrollments) in Sub-Saharan Africa (all income levels) in 2006?
Your response must be concise. -24. What is the difference between the Primary completion rate (% of total enrollments) in Low income in 1994 and the Primary completion rate (% of total enrollments) in Spain in 2006?
Provide a short and direct response. -51.32. What is the difference between the Primary completion rate (% of total enrollments) in Sub-Saharan Africa (all income levels) in 1994 and the Primary completion rate (% of total enrollments) in Spain in 2006?
Keep it short and to the point. -38.9. What is the difference between the Primary completion rate (% of total enrollments) in Euro area in 1994 and the Primary completion rate (% of total enrollments) in Low income in 2007?
Make the answer very short. 31.12. What is the difference between the Primary completion rate (% of total enrollments) in Euro area in 1994 and the Primary completion rate (% of total enrollments) in Sub-Saharan Africa (all income levels) in 2007?
Provide a short and direct response. 26.48. What is the difference between the Primary completion rate (% of total enrollments) of Euro area in 1994 and the Primary completion rate (% of total enrollments) of Spain in 2007?
Make the answer very short. -2.2. What is the difference between the Primary completion rate (% of total enrollments) of Low income in 1994 and the Primary completion rate (% of total enrollments) of Sub-Saharan Africa (all income levels) in 2007?
Give a very brief answer. -23.45. What is the difference between the Primary completion rate (% of total enrollments) in Low income in 1994 and the Primary completion rate (% of total enrollments) in Spain in 2007?
Provide a succinct answer. -52.13. What is the difference between the Primary completion rate (% of total enrollments) of Sub-Saharan Africa (all income levels) in 1994 and the Primary completion rate (% of total enrollments) of Spain in 2007?
Offer a very short reply. -39.72. What is the difference between the Primary completion rate (% of total enrollments) of Euro area in 1994 and the Primary completion rate (% of total enrollments) of Low income in 2008?
Provide a short and direct response. 28.77. What is the difference between the Primary completion rate (% of total enrollments) in Euro area in 1994 and the Primary completion rate (% of total enrollments) in Sub-Saharan Africa (all income levels) in 2008?
Make the answer very short. 26.85. What is the difference between the Primary completion rate (% of total enrollments) of Euro area in 1994 and the Primary completion rate (% of total enrollments) of Spain in 2008?
Your response must be concise. -3.35. What is the difference between the Primary completion rate (% of total enrollments) of Low income in 1994 and the Primary completion rate (% of total enrollments) of Sub-Saharan Africa (all income levels) in 2008?
Offer a very short reply. -23.08. What is the difference between the Primary completion rate (% of total enrollments) of Low income in 1994 and the Primary completion rate (% of total enrollments) of Spain in 2008?
Make the answer very short. -53.28. What is the difference between the Primary completion rate (% of total enrollments) of Sub-Saharan Africa (all income levels) in 1994 and the Primary completion rate (% of total enrollments) of Spain in 2008?
Offer a terse response. -40.87. What is the difference between the Primary completion rate (% of total enrollments) of Euro area in 2004 and the Primary completion rate (% of total enrollments) of Low income in 2006?
Offer a very short reply. 33.75. What is the difference between the Primary completion rate (% of total enrollments) of Euro area in 2004 and the Primary completion rate (% of total enrollments) of Sub-Saharan Africa (all income levels) in 2006?
Provide a short and direct response. 26.54. What is the difference between the Primary completion rate (% of total enrollments) of Euro area in 2004 and the Primary completion rate (% of total enrollments) of Spain in 2006?
Offer a very short reply. -0.77. What is the difference between the Primary completion rate (% of total enrollments) in Low income in 2004 and the Primary completion rate (% of total enrollments) in Sub-Saharan Africa (all income levels) in 2006?
Make the answer very short. -12.07. What is the difference between the Primary completion rate (% of total enrollments) in Low income in 2004 and the Primary completion rate (% of total enrollments) in Spain in 2006?
Offer a very short reply. -39.38. What is the difference between the Primary completion rate (% of total enrollments) in Sub-Saharan Africa (all income levels) in 2004 and the Primary completion rate (% of total enrollments) in Spain in 2006?
Make the answer very short. -32.33. What is the difference between the Primary completion rate (% of total enrollments) in Euro area in 2004 and the Primary completion rate (% of total enrollments) in Low income in 2007?
Ensure brevity in your answer.  31.73. What is the difference between the Primary completion rate (% of total enrollments) in Euro area in 2004 and the Primary completion rate (% of total enrollments) in Sub-Saharan Africa (all income levels) in 2007?
Ensure brevity in your answer.  27.1. What is the difference between the Primary completion rate (% of total enrollments) of Euro area in 2004 and the Primary completion rate (% of total enrollments) of Spain in 2007?
Make the answer very short. -1.59. What is the difference between the Primary completion rate (% of total enrollments) in Low income in 2004 and the Primary completion rate (% of total enrollments) in Sub-Saharan Africa (all income levels) in 2007?
Give a very brief answer. -11.51. What is the difference between the Primary completion rate (% of total enrollments) in Low income in 2004 and the Primary completion rate (% of total enrollments) in Spain in 2007?
Provide a short and direct response. -40.2. What is the difference between the Primary completion rate (% of total enrollments) in Sub-Saharan Africa (all income levels) in 2004 and the Primary completion rate (% of total enrollments) in Spain in 2007?
Your answer should be compact. -33.14. What is the difference between the Primary completion rate (% of total enrollments) of Euro area in 2004 and the Primary completion rate (% of total enrollments) of Low income in 2008?
Offer a very short reply. 29.38. What is the difference between the Primary completion rate (% of total enrollments) of Euro area in 2004 and the Primary completion rate (% of total enrollments) of Sub-Saharan Africa (all income levels) in 2008?
Your answer should be compact. 27.46. What is the difference between the Primary completion rate (% of total enrollments) of Euro area in 2004 and the Primary completion rate (% of total enrollments) of Spain in 2008?
Provide a succinct answer. -2.74. What is the difference between the Primary completion rate (% of total enrollments) of Low income in 2004 and the Primary completion rate (% of total enrollments) of Sub-Saharan Africa (all income levels) in 2008?
Your response must be concise. -11.15. What is the difference between the Primary completion rate (% of total enrollments) in Low income in 2004 and the Primary completion rate (% of total enrollments) in Spain in 2008?
Make the answer very short. -41.35. What is the difference between the Primary completion rate (% of total enrollments) of Sub-Saharan Africa (all income levels) in 2004 and the Primary completion rate (% of total enrollments) of Spain in 2008?
Your answer should be very brief. -34.29. What is the difference between the Primary completion rate (% of total enrollments) of Euro area in 2006 and the Primary completion rate (% of total enrollments) of Low income in 2007?
Keep it short and to the point. 30.71. What is the difference between the Primary completion rate (% of total enrollments) of Euro area in 2006 and the Primary completion rate (% of total enrollments) of Sub-Saharan Africa (all income levels) in 2007?
Provide a short and direct response. 26.07. What is the difference between the Primary completion rate (% of total enrollments) in Euro area in 2006 and the Primary completion rate (% of total enrollments) in Spain in 2007?
Your answer should be compact. -2.61. What is the difference between the Primary completion rate (% of total enrollments) of Low income in 2006 and the Primary completion rate (% of total enrollments) of Sub-Saharan Africa (all income levels) in 2007?
Ensure brevity in your answer.  -6.65. What is the difference between the Primary completion rate (% of total enrollments) of Low income in 2006 and the Primary completion rate (% of total enrollments) of Spain in 2007?
Your response must be concise. -35.34. What is the difference between the Primary completion rate (% of total enrollments) in Sub-Saharan Africa (all income levels) in 2006 and the Primary completion rate (% of total enrollments) in Spain in 2007?
Give a very brief answer. -28.13. What is the difference between the Primary completion rate (% of total enrollments) in Euro area in 2006 and the Primary completion rate (% of total enrollments) in Low income in 2008?
Offer a terse response. 28.36. What is the difference between the Primary completion rate (% of total enrollments) in Euro area in 2006 and the Primary completion rate (% of total enrollments) in Sub-Saharan Africa (all income levels) in 2008?
Give a very brief answer. 26.43. What is the difference between the Primary completion rate (% of total enrollments) of Euro area in 2006 and the Primary completion rate (% of total enrollments) of Spain in 2008?
Your response must be concise. -3.76. What is the difference between the Primary completion rate (% of total enrollments) in Low income in 2006 and the Primary completion rate (% of total enrollments) in Sub-Saharan Africa (all income levels) in 2008?
Your response must be concise. -6.29. What is the difference between the Primary completion rate (% of total enrollments) in Low income in 2006 and the Primary completion rate (% of total enrollments) in Spain in 2008?
Offer a very short reply. -36.49. What is the difference between the Primary completion rate (% of total enrollments) in Sub-Saharan Africa (all income levels) in 2006 and the Primary completion rate (% of total enrollments) in Spain in 2008?
Make the answer very short. -29.28. What is the difference between the Primary completion rate (% of total enrollments) in Euro area in 2007 and the Primary completion rate (% of total enrollments) in Low income in 2008?
Offer a very short reply. 30.06. What is the difference between the Primary completion rate (% of total enrollments) in Euro area in 2007 and the Primary completion rate (% of total enrollments) in Sub-Saharan Africa (all income levels) in 2008?
Make the answer very short. 28.13. What is the difference between the Primary completion rate (% of total enrollments) of Euro area in 2007 and the Primary completion rate (% of total enrollments) of Spain in 2008?
Your answer should be very brief. -2.06. What is the difference between the Primary completion rate (% of total enrollments) in Low income in 2007 and the Primary completion rate (% of total enrollments) in Sub-Saharan Africa (all income levels) in 2008?
Offer a very short reply. -4.27. What is the difference between the Primary completion rate (% of total enrollments) of Low income in 2007 and the Primary completion rate (% of total enrollments) of Spain in 2008?
Ensure brevity in your answer.  -34.47. What is the difference between the Primary completion rate (% of total enrollments) in Sub-Saharan Africa (all income levels) in 2007 and the Primary completion rate (% of total enrollments) in Spain in 2008?
Your answer should be very brief. -29.84. What is the average Primary completion rate (% of total enrollments) in Euro area per year?
Ensure brevity in your answer.  97.37. What is the average Primary completion rate (% of total enrollments) in Low income per year?
Offer a very short reply. 55.12. What is the average Primary completion rate (% of total enrollments) of Sub-Saharan Africa (all income levels) per year?
Offer a very short reply. 64.21. What is the average Primary completion rate (% of total enrollments) of Spain per year?
Offer a very short reply. 101.66. In the year 1989, what is the difference between the Primary completion rate (% of total enrollments) of Euro area and Primary completion rate (% of total enrollments) of Low income?
Your response must be concise. 52.96. In the year 1989, what is the difference between the Primary completion rate (% of total enrollments) in Euro area and Primary completion rate (% of total enrollments) in Sub-Saharan Africa (all income levels)?
Offer a very short reply. 38.8. In the year 1989, what is the difference between the Primary completion rate (% of total enrollments) of Euro area and Primary completion rate (% of total enrollments) of Spain?
Your answer should be compact. -8.35. In the year 1989, what is the difference between the Primary completion rate (% of total enrollments) in Low income and Primary completion rate (% of total enrollments) in Sub-Saharan Africa (all income levels)?
Offer a terse response. -14.16. In the year 1989, what is the difference between the Primary completion rate (% of total enrollments) of Low income and Primary completion rate (% of total enrollments) of Spain?
Offer a terse response. -61.31. In the year 1989, what is the difference between the Primary completion rate (% of total enrollments) of Sub-Saharan Africa (all income levels) and Primary completion rate (% of total enrollments) of Spain?
Make the answer very short. -47.15. In the year 1990, what is the difference between the Primary completion rate (% of total enrollments) in Euro area and Primary completion rate (% of total enrollments) in Low income?
Your response must be concise. 51.55. In the year 1990, what is the difference between the Primary completion rate (% of total enrollments) of Euro area and Primary completion rate (% of total enrollments) of Sub-Saharan Africa (all income levels)?
Your answer should be compact. 38.31. In the year 1990, what is the difference between the Primary completion rate (% of total enrollments) in Euro area and Primary completion rate (% of total enrollments) in Spain?
Give a very brief answer. -4.08. In the year 1990, what is the difference between the Primary completion rate (% of total enrollments) in Low income and Primary completion rate (% of total enrollments) in Sub-Saharan Africa (all income levels)?
Offer a terse response. -13.24. In the year 1990, what is the difference between the Primary completion rate (% of total enrollments) of Low income and Primary completion rate (% of total enrollments) of Spain?
Make the answer very short. -55.63. In the year 1990, what is the difference between the Primary completion rate (% of total enrollments) of Sub-Saharan Africa (all income levels) and Primary completion rate (% of total enrollments) of Spain?
Keep it short and to the point. -42.39. In the year 1993, what is the difference between the Primary completion rate (% of total enrollments) of Euro area and Primary completion rate (% of total enrollments) of Low income?
Offer a terse response. 49.39. In the year 1993, what is the difference between the Primary completion rate (% of total enrollments) of Euro area and Primary completion rate (% of total enrollments) of Sub-Saharan Africa (all income levels)?
Keep it short and to the point. 37.28. In the year 1993, what is the difference between the Primary completion rate (% of total enrollments) in Euro area and Primary completion rate (% of total enrollments) in Spain?
Your response must be concise. -4.56. In the year 1993, what is the difference between the Primary completion rate (% of total enrollments) in Low income and Primary completion rate (% of total enrollments) in Sub-Saharan Africa (all income levels)?
Your answer should be compact. -12.11. In the year 1993, what is the difference between the Primary completion rate (% of total enrollments) of Low income and Primary completion rate (% of total enrollments) of Spain?
Your response must be concise. -53.95. In the year 1993, what is the difference between the Primary completion rate (% of total enrollments) of Sub-Saharan Africa (all income levels) and Primary completion rate (% of total enrollments) of Spain?
Offer a terse response. -41.84. In the year 1994, what is the difference between the Primary completion rate (% of total enrollments) of Euro area and Primary completion rate (% of total enrollments) of Low income?
Your answer should be compact. 49.93. In the year 1994, what is the difference between the Primary completion rate (% of total enrollments) in Euro area and Primary completion rate (% of total enrollments) in Sub-Saharan Africa (all income levels)?
Your answer should be compact. 37.52. In the year 1994, what is the difference between the Primary completion rate (% of total enrollments) of Euro area and Primary completion rate (% of total enrollments) of Spain?
Ensure brevity in your answer.  -6.49. In the year 1994, what is the difference between the Primary completion rate (% of total enrollments) in Low income and Primary completion rate (% of total enrollments) in Sub-Saharan Africa (all income levels)?
Your response must be concise. -12.41. In the year 1994, what is the difference between the Primary completion rate (% of total enrollments) of Low income and Primary completion rate (% of total enrollments) of Spain?
Offer a terse response. -56.42. In the year 1994, what is the difference between the Primary completion rate (% of total enrollments) in Sub-Saharan Africa (all income levels) and Primary completion rate (% of total enrollments) in Spain?
Provide a short and direct response. -44. In the year 2004, what is the difference between the Primary completion rate (% of total enrollments) of Euro area and Primary completion rate (% of total enrollments) of Low income?
Offer a terse response. 38.61. In the year 2004, what is the difference between the Primary completion rate (% of total enrollments) in Euro area and Primary completion rate (% of total enrollments) in Sub-Saharan Africa (all income levels)?
Make the answer very short. 31.55. In the year 2004, what is the difference between the Primary completion rate (% of total enrollments) of Euro area and Primary completion rate (% of total enrollments) of Spain?
Ensure brevity in your answer.  -6.41. In the year 2004, what is the difference between the Primary completion rate (% of total enrollments) of Low income and Primary completion rate (% of total enrollments) of Sub-Saharan Africa (all income levels)?
Offer a very short reply. -7.06. In the year 2004, what is the difference between the Primary completion rate (% of total enrollments) in Low income and Primary completion rate (% of total enrollments) in Spain?
Keep it short and to the point. -45.02. In the year 2004, what is the difference between the Primary completion rate (% of total enrollments) in Sub-Saharan Africa (all income levels) and Primary completion rate (% of total enrollments) in Spain?
Give a very brief answer. -37.96. In the year 2006, what is the difference between the Primary completion rate (% of total enrollments) of Euro area and Primary completion rate (% of total enrollments) of Low income?
Your answer should be very brief. 32.73. In the year 2006, what is the difference between the Primary completion rate (% of total enrollments) of Euro area and Primary completion rate (% of total enrollments) of Sub-Saharan Africa (all income levels)?
Provide a short and direct response. 25.52. In the year 2006, what is the difference between the Primary completion rate (% of total enrollments) in Euro area and Primary completion rate (% of total enrollments) in Spain?
Offer a very short reply. -1.8. In the year 2006, what is the difference between the Primary completion rate (% of total enrollments) in Low income and Primary completion rate (% of total enrollments) in Sub-Saharan Africa (all income levels)?
Your answer should be compact. -7.21. In the year 2006, what is the difference between the Primary completion rate (% of total enrollments) in Low income and Primary completion rate (% of total enrollments) in Spain?
Your response must be concise. -34.52. In the year 2006, what is the difference between the Primary completion rate (% of total enrollments) of Sub-Saharan Africa (all income levels) and Primary completion rate (% of total enrollments) of Spain?
Ensure brevity in your answer.  -27.32. In the year 2007, what is the difference between the Primary completion rate (% of total enrollments) in Euro area and Primary completion rate (% of total enrollments) in Low income?
Provide a succinct answer. 32.41. In the year 2007, what is the difference between the Primary completion rate (% of total enrollments) in Euro area and Primary completion rate (% of total enrollments) in Sub-Saharan Africa (all income levels)?
Provide a succinct answer. 27.77. In the year 2007, what is the difference between the Primary completion rate (% of total enrollments) of Euro area and Primary completion rate (% of total enrollments) of Spain?
Your response must be concise. -0.91. In the year 2007, what is the difference between the Primary completion rate (% of total enrollments) in Low income and Primary completion rate (% of total enrollments) in Sub-Saharan Africa (all income levels)?
Offer a terse response. -4.64. In the year 2007, what is the difference between the Primary completion rate (% of total enrollments) of Low income and Primary completion rate (% of total enrollments) of Spain?
Give a very brief answer. -33.32. In the year 2007, what is the difference between the Primary completion rate (% of total enrollments) in Sub-Saharan Africa (all income levels) and Primary completion rate (% of total enrollments) in Spain?
Provide a short and direct response. -28.69. In the year 2008, what is the difference between the Primary completion rate (% of total enrollments) in Euro area and Primary completion rate (% of total enrollments) in Low income?
Make the answer very short. 30.41. In the year 2008, what is the difference between the Primary completion rate (% of total enrollments) in Euro area and Primary completion rate (% of total enrollments) in Sub-Saharan Africa (all income levels)?
Make the answer very short. 28.49. In the year 2008, what is the difference between the Primary completion rate (% of total enrollments) of Euro area and Primary completion rate (% of total enrollments) of Spain?
Offer a terse response. -1.71. In the year 2008, what is the difference between the Primary completion rate (% of total enrollments) in Low income and Primary completion rate (% of total enrollments) in Sub-Saharan Africa (all income levels)?
Your answer should be very brief. -1.92. In the year 2008, what is the difference between the Primary completion rate (% of total enrollments) of Low income and Primary completion rate (% of total enrollments) of Spain?
Your answer should be very brief. -32.12. In the year 2008, what is the difference between the Primary completion rate (% of total enrollments) of Sub-Saharan Africa (all income levels) and Primary completion rate (% of total enrollments) of Spain?
Provide a short and direct response. -30.2. What is the ratio of the Primary completion rate (% of total enrollments) in Low income in 1989 to that in 1990?
Provide a succinct answer. 0.97. What is the ratio of the Primary completion rate (% of total enrollments) of Sub-Saharan Africa (all income levels) in 1989 to that in 1990?
Offer a very short reply. 0.99. What is the ratio of the Primary completion rate (% of total enrollments) in Spain in 1989 to that in 1990?
Provide a succinct answer. 1.04. What is the ratio of the Primary completion rate (% of total enrollments) in Euro area in 1989 to that in 1993?
Keep it short and to the point. 1.01. What is the ratio of the Primary completion rate (% of total enrollments) in Low income in 1989 to that in 1993?
Keep it short and to the point. 0.94. What is the ratio of the Primary completion rate (% of total enrollments) of Sub-Saharan Africa (all income levels) in 1989 to that in 1993?
Offer a terse response. 0.98. What is the ratio of the Primary completion rate (% of total enrollments) in Spain in 1989 to that in 1993?
Your answer should be compact. 1.04. What is the ratio of the Primary completion rate (% of total enrollments) in Euro area in 1989 to that in 1994?
Give a very brief answer. 1.01. What is the ratio of the Primary completion rate (% of total enrollments) of Low income in 1989 to that in 1994?
Your response must be concise. 0.96. What is the ratio of the Primary completion rate (% of total enrollments) of Sub-Saharan Africa (all income levels) in 1989 to that in 1994?
Your answer should be compact. 1. What is the ratio of the Primary completion rate (% of total enrollments) of Spain in 1989 to that in 1994?
Your answer should be compact. 1.03. What is the ratio of the Primary completion rate (% of total enrollments) in Euro area in 1989 to that in 2004?
Your answer should be very brief. 1.01. What is the ratio of the Primary completion rate (% of total enrollments) in Low income in 1989 to that in 2004?
Make the answer very short. 0.77. What is the ratio of the Primary completion rate (% of total enrollments) of Sub-Saharan Africa (all income levels) in 1989 to that in 2004?
Keep it short and to the point. 0.9. What is the ratio of the Primary completion rate (% of total enrollments) of Spain in 1989 to that in 2004?
Give a very brief answer. 1.03. What is the ratio of the Primary completion rate (% of total enrollments) in Euro area in 1989 to that in 2006?
Provide a short and direct response. 1.02. What is the ratio of the Primary completion rate (% of total enrollments) of Low income in 1989 to that in 2006?
Your answer should be compact. 0.71. What is the ratio of the Primary completion rate (% of total enrollments) of Sub-Saharan Africa (all income levels) in 1989 to that in 2006?
Offer a very short reply. 0.84. What is the ratio of the Primary completion rate (% of total enrollments) in Spain in 1989 to that in 2006?
Your response must be concise. 1.08. What is the ratio of the Primary completion rate (% of total enrollments) in Euro area in 1989 to that in 2007?
Offer a terse response. 1. What is the ratio of the Primary completion rate (% of total enrollments) in Low income in 1989 to that in 2007?
Ensure brevity in your answer.  0.69. What is the ratio of the Primary completion rate (% of total enrollments) of Sub-Saharan Africa (all income levels) in 1989 to that in 2007?
Keep it short and to the point. 0.84. What is the ratio of the Primary completion rate (% of total enrollments) in Spain in 1989 to that in 2007?
Offer a terse response. 1.08. What is the ratio of the Primary completion rate (% of total enrollments) of Euro area in 1989 to that in 2008?
Ensure brevity in your answer.  1. What is the ratio of the Primary completion rate (% of total enrollments) in Low income in 1989 to that in 2008?
Ensure brevity in your answer.  0.66. What is the ratio of the Primary completion rate (% of total enrollments) in Sub-Saharan Africa (all income levels) in 1989 to that in 2008?
Your answer should be very brief. 0.85. What is the ratio of the Primary completion rate (% of total enrollments) in Spain in 1989 to that in 2008?
Make the answer very short. 1.06. What is the ratio of the Primary completion rate (% of total enrollments) in Euro area in 1990 to that in 1993?
Your answer should be very brief. 1.01. What is the ratio of the Primary completion rate (% of total enrollments) of Low income in 1990 to that in 1993?
Ensure brevity in your answer.  0.97. What is the ratio of the Primary completion rate (% of total enrollments) in Sub-Saharan Africa (all income levels) in 1990 to that in 1993?
Keep it short and to the point. 0.99. What is the ratio of the Primary completion rate (% of total enrollments) in Euro area in 1990 to that in 1994?
Make the answer very short. 1.01. What is the ratio of the Primary completion rate (% of total enrollments) in Sub-Saharan Africa (all income levels) in 1990 to that in 1994?
Your answer should be compact. 1.01. What is the ratio of the Primary completion rate (% of total enrollments) in Spain in 1990 to that in 1994?
Make the answer very short. 0.99. What is the ratio of the Primary completion rate (% of total enrollments) of Euro area in 1990 to that in 2004?
Provide a succinct answer. 1.01. What is the ratio of the Primary completion rate (% of total enrollments) of Low income in 1990 to that in 2004?
Your answer should be very brief. 0.79. What is the ratio of the Primary completion rate (% of total enrollments) in Sub-Saharan Africa (all income levels) in 1990 to that in 2004?
Your answer should be very brief. 0.91. What is the ratio of the Primary completion rate (% of total enrollments) of Spain in 1990 to that in 2004?
Give a very brief answer. 0.98. What is the ratio of the Primary completion rate (% of total enrollments) of Euro area in 1990 to that in 2006?
Provide a short and direct response. 1.02. What is the ratio of the Primary completion rate (% of total enrollments) in Low income in 1990 to that in 2006?
Offer a very short reply. 0.73. What is the ratio of the Primary completion rate (% of total enrollments) of Sub-Saharan Africa (all income levels) in 1990 to that in 2006?
Make the answer very short. 0.84. What is the ratio of the Primary completion rate (% of total enrollments) of Spain in 1990 to that in 2006?
Your answer should be very brief. 1.04. What is the ratio of the Primary completion rate (% of total enrollments) in Low income in 1990 to that in 2007?
Give a very brief answer. 0.71. What is the ratio of the Primary completion rate (% of total enrollments) in Sub-Saharan Africa (all income levels) in 1990 to that in 2007?
Your response must be concise. 0.85. What is the ratio of the Primary completion rate (% of total enrollments) in Spain in 1990 to that in 2007?
Provide a succinct answer. 1.03. What is the ratio of the Primary completion rate (% of total enrollments) in Low income in 1990 to that in 2008?
Offer a very short reply. 0.68. What is the ratio of the Primary completion rate (% of total enrollments) of Sub-Saharan Africa (all income levels) in 1990 to that in 2008?
Offer a very short reply. 0.85. What is the ratio of the Primary completion rate (% of total enrollments) in Spain in 1990 to that in 2008?
Keep it short and to the point. 1.02. What is the ratio of the Primary completion rate (% of total enrollments) in Euro area in 1993 to that in 1994?
Make the answer very short. 1.01. What is the ratio of the Primary completion rate (% of total enrollments) in Low income in 1993 to that in 1994?
Give a very brief answer. 1.03. What is the ratio of the Primary completion rate (% of total enrollments) in Sub-Saharan Africa (all income levels) in 1993 to that in 1994?
Provide a succinct answer. 1.02. What is the ratio of the Primary completion rate (% of total enrollments) in Spain in 1993 to that in 1994?
Provide a short and direct response. 0.99. What is the ratio of the Primary completion rate (% of total enrollments) in Low income in 1993 to that in 2004?
Make the answer very short. 0.82. What is the ratio of the Primary completion rate (% of total enrollments) in Sub-Saharan Africa (all income levels) in 1993 to that in 2004?
Your response must be concise. 0.92. What is the ratio of the Primary completion rate (% of total enrollments) of Spain in 1993 to that in 2004?
Provide a succinct answer. 0.98. What is the ratio of the Primary completion rate (% of total enrollments) of Euro area in 1993 to that in 2006?
Provide a succinct answer. 1.01. What is the ratio of the Primary completion rate (% of total enrollments) in Low income in 1993 to that in 2006?
Your answer should be very brief. 0.76. What is the ratio of the Primary completion rate (% of total enrollments) of Sub-Saharan Africa (all income levels) in 1993 to that in 2006?
Give a very brief answer. 0.85. What is the ratio of the Primary completion rate (% of total enrollments) of Spain in 1993 to that in 2006?
Give a very brief answer. 1.04. What is the ratio of the Primary completion rate (% of total enrollments) of Low income in 1993 to that in 2007?
Make the answer very short. 0.73. What is the ratio of the Primary completion rate (% of total enrollments) in Sub-Saharan Africa (all income levels) in 1993 to that in 2007?
Provide a short and direct response. 0.86. What is the ratio of the Primary completion rate (% of total enrollments) in Spain in 1993 to that in 2007?
Your response must be concise. 1.03. What is the ratio of the Primary completion rate (% of total enrollments) in Low income in 1993 to that in 2008?
Give a very brief answer. 0.71. What is the ratio of the Primary completion rate (% of total enrollments) of Sub-Saharan Africa (all income levels) in 1993 to that in 2008?
Your answer should be compact. 0.86. What is the ratio of the Primary completion rate (% of total enrollments) of Spain in 1993 to that in 2008?
Give a very brief answer. 1.02. What is the ratio of the Primary completion rate (% of total enrollments) in Euro area in 1994 to that in 2004?
Your answer should be very brief. 0.99. What is the ratio of the Primary completion rate (% of total enrollments) of Low income in 1994 to that in 2004?
Make the answer very short. 0.8. What is the ratio of the Primary completion rate (% of total enrollments) of Sub-Saharan Africa (all income levels) in 1994 to that in 2004?
Make the answer very short. 0.9. What is the ratio of the Primary completion rate (% of total enrollments) of Spain in 1994 to that in 2004?
Provide a succinct answer. 0.99. What is the ratio of the Primary completion rate (% of total enrollments) in Euro area in 1994 to that in 2006?
Provide a short and direct response. 1. What is the ratio of the Primary completion rate (% of total enrollments) in Low income in 1994 to that in 2006?
Provide a succinct answer. 0.74. What is the ratio of the Primary completion rate (% of total enrollments) of Sub-Saharan Africa (all income levels) in 1994 to that in 2006?
Make the answer very short. 0.84. What is the ratio of the Primary completion rate (% of total enrollments) in Spain in 1994 to that in 2006?
Your answer should be very brief. 1.05. What is the ratio of the Primary completion rate (% of total enrollments) of Low income in 1994 to that in 2007?
Your response must be concise. 0.71. What is the ratio of the Primary completion rate (% of total enrollments) of Sub-Saharan Africa (all income levels) in 1994 to that in 2007?
Give a very brief answer. 0.84. What is the ratio of the Primary completion rate (% of total enrollments) of Spain in 1994 to that in 2007?
Give a very brief answer. 1.04. What is the ratio of the Primary completion rate (% of total enrollments) of Euro area in 1994 to that in 2008?
Your answer should be compact. 0.98. What is the ratio of the Primary completion rate (% of total enrollments) in Low income in 1994 to that in 2008?
Offer a terse response. 0.69. What is the ratio of the Primary completion rate (% of total enrollments) of Sub-Saharan Africa (all income levels) in 1994 to that in 2008?
Keep it short and to the point. 0.85. What is the ratio of the Primary completion rate (% of total enrollments) in Spain in 1994 to that in 2008?
Offer a terse response. 1.03. What is the ratio of the Primary completion rate (% of total enrollments) of Euro area in 2004 to that in 2006?
Ensure brevity in your answer.  1.01. What is the ratio of the Primary completion rate (% of total enrollments) in Low income in 2004 to that in 2006?
Provide a short and direct response. 0.92. What is the ratio of the Primary completion rate (% of total enrollments) in Sub-Saharan Africa (all income levels) in 2004 to that in 2006?
Ensure brevity in your answer.  0.93. What is the ratio of the Primary completion rate (% of total enrollments) in Spain in 2004 to that in 2006?
Your answer should be compact. 1.06. What is the ratio of the Primary completion rate (% of total enrollments) in Euro area in 2004 to that in 2007?
Make the answer very short. 0.99. What is the ratio of the Primary completion rate (% of total enrollments) in Low income in 2004 to that in 2007?
Provide a short and direct response. 0.89. What is the ratio of the Primary completion rate (% of total enrollments) in Sub-Saharan Africa (all income levels) in 2004 to that in 2007?
Ensure brevity in your answer.  0.94. What is the ratio of the Primary completion rate (% of total enrollments) of Spain in 2004 to that in 2007?
Offer a very short reply. 1.05. What is the ratio of the Primary completion rate (% of total enrollments) in Low income in 2004 to that in 2008?
Make the answer very short. 0.86. What is the ratio of the Primary completion rate (% of total enrollments) of Sub-Saharan Africa (all income levels) in 2004 to that in 2008?
Offer a very short reply. 0.94. What is the ratio of the Primary completion rate (% of total enrollments) of Spain in 2004 to that in 2008?
Keep it short and to the point. 1.04. What is the ratio of the Primary completion rate (% of total enrollments) in Euro area in 2006 to that in 2007?
Your response must be concise. 0.98. What is the ratio of the Primary completion rate (% of total enrollments) in Low income in 2006 to that in 2007?
Ensure brevity in your answer.  0.97. What is the ratio of the Primary completion rate (% of total enrollments) in Sub-Saharan Africa (all income levels) in 2006 to that in 2007?
Provide a succinct answer. 1.01. What is the ratio of the Primary completion rate (% of total enrollments) in Euro area in 2006 to that in 2008?
Your answer should be very brief. 0.98. What is the ratio of the Primary completion rate (% of total enrollments) in Low income in 2006 to that in 2008?
Offer a terse response. 0.94. What is the ratio of the Primary completion rate (% of total enrollments) in Sub-Saharan Africa (all income levels) in 2006 to that in 2008?
Your response must be concise. 1.01. What is the ratio of the Primary completion rate (% of total enrollments) in Spain in 2006 to that in 2008?
Give a very brief answer. 0.98. What is the ratio of the Primary completion rate (% of total enrollments) in Low income in 2007 to that in 2008?
Offer a very short reply. 0.97. What is the ratio of the Primary completion rate (% of total enrollments) of Spain in 2007 to that in 2008?
Your response must be concise. 0.99. What is the difference between the highest and the second highest Primary completion rate (% of total enrollments) of Euro area?
Provide a succinct answer. 0.29. What is the difference between the highest and the second highest Primary completion rate (% of total enrollments) in Low income?
Offer a very short reply. 2.35. What is the difference between the highest and the second highest Primary completion rate (% of total enrollments) of Sub-Saharan Africa (all income levels)?
Your response must be concise. 0.55. What is the difference between the highest and the second highest Primary completion rate (% of total enrollments) in Spain?
Your response must be concise. 2.65. What is the difference between the highest and the lowest Primary completion rate (% of total enrollments) of Euro area?
Offer a terse response. 2.05. What is the difference between the highest and the lowest Primary completion rate (% of total enrollments) of Low income?
Your answer should be very brief. 22.88. What is the difference between the highest and the lowest Primary completion rate (% of total enrollments) in Sub-Saharan Africa (all income levels)?
Your answer should be compact. 11.58. What is the difference between the highest and the lowest Primary completion rate (% of total enrollments) in Spain?
Your response must be concise. 8.28. 